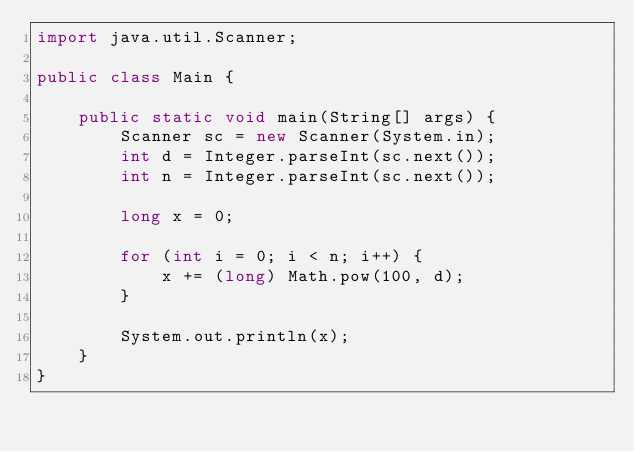<code> <loc_0><loc_0><loc_500><loc_500><_Java_>import java.util.Scanner;

public class Main {

	public static void main(String[] args) {
		Scanner sc = new Scanner(System.in);
		int d = Integer.parseInt(sc.next());
		int n = Integer.parseInt(sc.next());

		long x = 0;

		for (int i = 0; i < n; i++) {
			x += (long) Math.pow(100, d);
		}

		System.out.println(x);
	}
}
</code> 